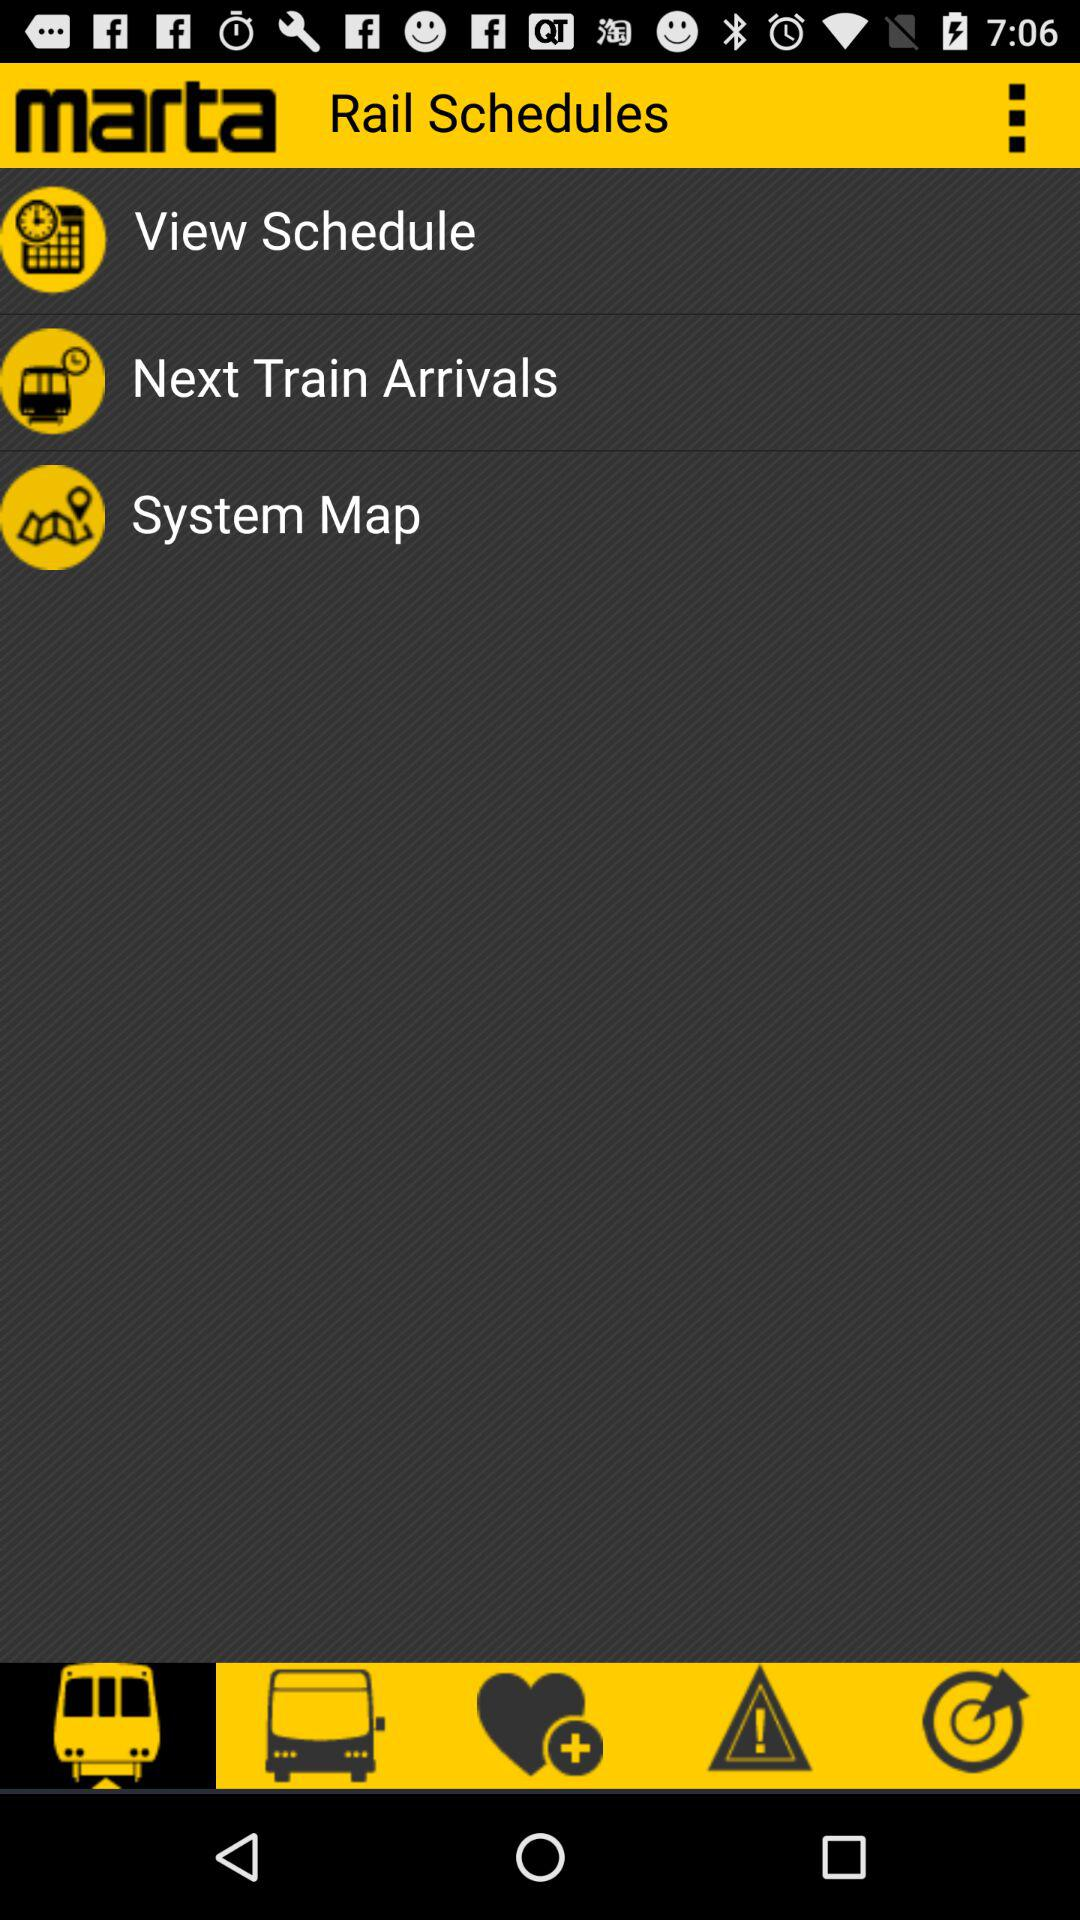When does the next train arrive?
When the provided information is insufficient, respond with <no answer>. <no answer> 